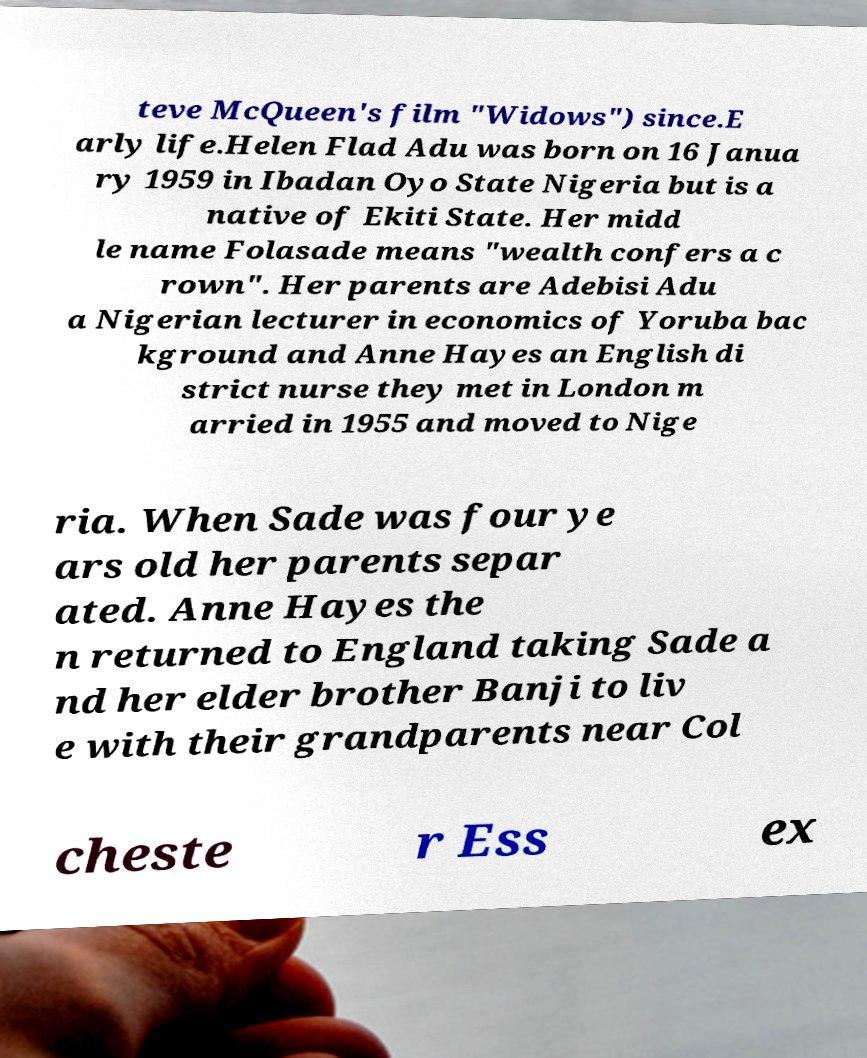Can you read and provide the text displayed in the image?This photo seems to have some interesting text. Can you extract and type it out for me? teve McQueen's film "Widows") since.E arly life.Helen Flad Adu was born on 16 Janua ry 1959 in Ibadan Oyo State Nigeria but is a native of Ekiti State. Her midd le name Folasade means "wealth confers a c rown". Her parents are Adebisi Adu a Nigerian lecturer in economics of Yoruba bac kground and Anne Hayes an English di strict nurse they met in London m arried in 1955 and moved to Nige ria. When Sade was four ye ars old her parents separ ated. Anne Hayes the n returned to England taking Sade a nd her elder brother Banji to liv e with their grandparents near Col cheste r Ess ex 